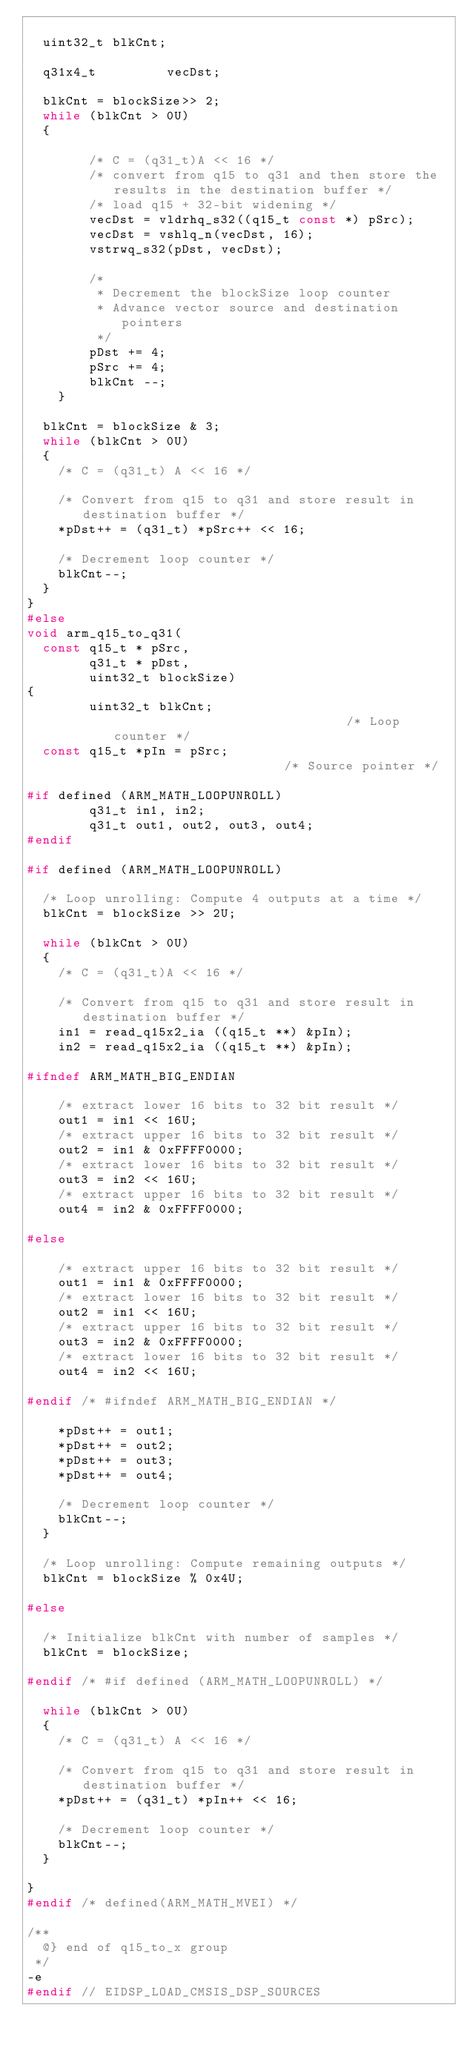<code> <loc_0><loc_0><loc_500><loc_500><_C_>
  uint32_t blkCnt;

  q31x4_t         vecDst;

  blkCnt = blockSize>> 2;
  while (blkCnt > 0U)
  {

        /* C = (q31_t)A << 16 */
        /* convert from q15 to q31 and then store the results in the destination buffer */
        /* load q15 + 32-bit widening */
        vecDst = vldrhq_s32((q15_t const *) pSrc);
        vecDst = vshlq_n(vecDst, 16);
        vstrwq_s32(pDst, vecDst);

        /*
         * Decrement the blockSize loop counter
         * Advance vector source and destination pointers
         */
        pDst += 4;
        pSrc += 4;
        blkCnt --;
    }

  blkCnt = blockSize & 3;
  while (blkCnt > 0U)
  {
    /* C = (q31_t) A << 16 */

    /* Convert from q15 to q31 and store result in destination buffer */
    *pDst++ = (q31_t) *pSrc++ << 16;

    /* Decrement loop counter */
    blkCnt--;
  }
}
#else
void arm_q15_to_q31(
  const q15_t * pSrc,
        q31_t * pDst,
        uint32_t blockSize)
{
        uint32_t blkCnt;                               /* Loop counter */
  const q15_t *pIn = pSrc;                             /* Source pointer */

#if defined (ARM_MATH_LOOPUNROLL)
        q31_t in1, in2;
        q31_t out1, out2, out3, out4;
#endif

#if defined (ARM_MATH_LOOPUNROLL)

  /* Loop unrolling: Compute 4 outputs at a time */
  blkCnt = blockSize >> 2U;

  while (blkCnt > 0U)
  {
    /* C = (q31_t)A << 16 */

    /* Convert from q15 to q31 and store result in destination buffer */
    in1 = read_q15x2_ia ((q15_t **) &pIn);
    in2 = read_q15x2_ia ((q15_t **) &pIn);

#ifndef ARM_MATH_BIG_ENDIAN

    /* extract lower 16 bits to 32 bit result */
    out1 = in1 << 16U;
    /* extract upper 16 bits to 32 bit result */
    out2 = in1 & 0xFFFF0000;
    /* extract lower 16 bits to 32 bit result */
    out3 = in2 << 16U;
    /* extract upper 16 bits to 32 bit result */
    out4 = in2 & 0xFFFF0000;

#else

    /* extract upper 16 bits to 32 bit result */
    out1 = in1 & 0xFFFF0000;
    /* extract lower 16 bits to 32 bit result */
    out2 = in1 << 16U;
    /* extract upper 16 bits to 32 bit result */
    out3 = in2 & 0xFFFF0000;
    /* extract lower 16 bits to 32 bit result */
    out4 = in2 << 16U;

#endif /* #ifndef ARM_MATH_BIG_ENDIAN */

    *pDst++ = out1;
    *pDst++ = out2;
    *pDst++ = out3;
    *pDst++ = out4;

    /* Decrement loop counter */
    blkCnt--;
  }

  /* Loop unrolling: Compute remaining outputs */
  blkCnt = blockSize % 0x4U;

#else

  /* Initialize blkCnt with number of samples */
  blkCnt = blockSize;

#endif /* #if defined (ARM_MATH_LOOPUNROLL) */

  while (blkCnt > 0U)
  {
    /* C = (q31_t) A << 16 */

    /* Convert from q15 to q31 and store result in destination buffer */
    *pDst++ = (q31_t) *pIn++ << 16;

    /* Decrement loop counter */
    blkCnt--;
  }

}
#endif /* defined(ARM_MATH_MVEI) */

/**
  @} end of q15_to_x group
 */
-e 
#endif // EIDSP_LOAD_CMSIS_DSP_SOURCES
</code> 